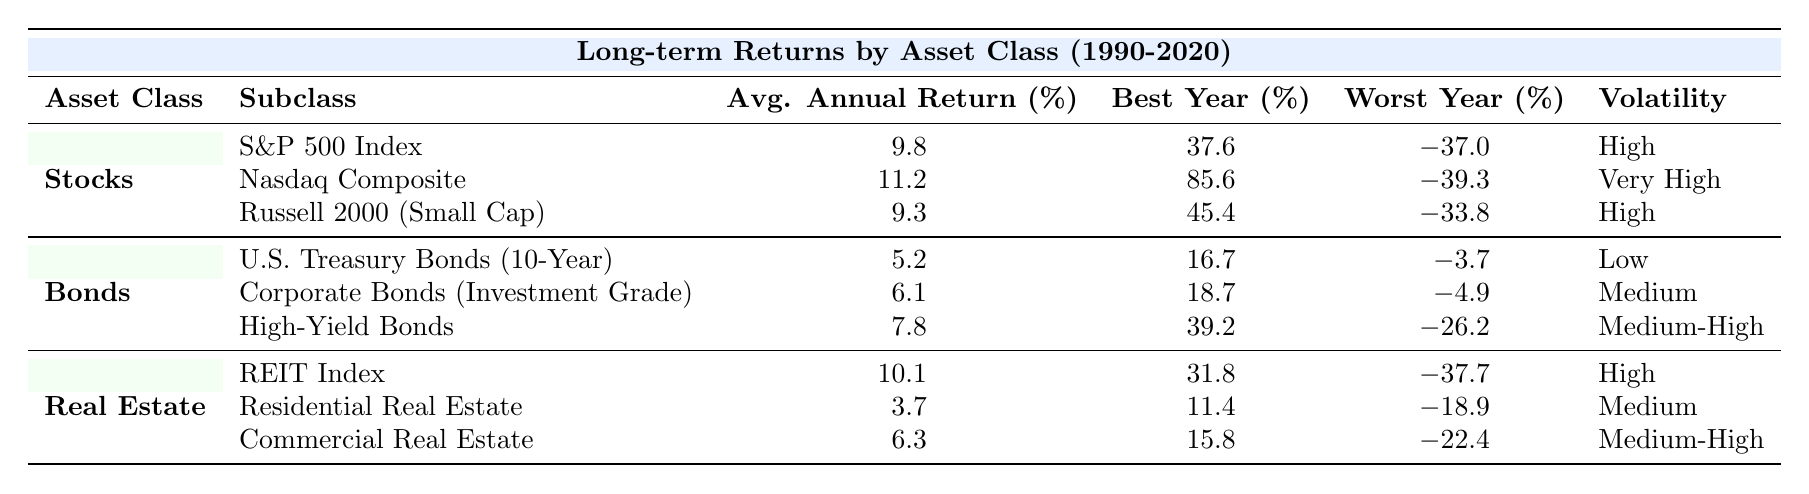What is the average annual return of the Nasdaq Composite? The table lists the average annual return for the Nasdaq Composite as 11.2%.
Answer: 11.2% Which asset class has the highest worst year return? By comparing the worst year returns across asset classes, the Nasdaq Composite has the worst year of -39.3% (2000), but Real Estate (REIT Index) also has a worst year of -37.7% (2008). Since both are similar, Real Estate has the highest worst year return in relative ranking (less negative).
Answer: Real Estate What is the volatility of Corporate Bonds? The table states that the volatility of Corporate Bonds (Investment Grade) is classified as Medium.
Answer: Medium Which asset class has the best average annual return overall? The highest average annual return is from the Nasdaq Composite at 11.2%. Therefore, among asset classes, Stocks would rank highest, specifically the Nasdaq Composite.
Answer: Stocks If you combine the average annual returns of U.S. Treasury Bonds and Corporate Bonds, what is the total? U.S. Treasury Bonds have an average annual return of 5.2% and Corporate Bonds at 6.1%. Adding them gives 5.2 + 6.1 = 11.3%.
Answer: 11.3% Is there any asset class that had a best year return above 30%? Yes, both the Nasdaq Composite (best year return of 85.6% in 1999) and REIT Index (best year return of 31.8% in 2014) had best year returns above 30%.
Answer: Yes What is the average annual return of Real Estate compared to Bonds? The average annual return for Real Estate (10.1% for REIT Index, 3.7% for Residential Real Estate, and 6.3% for Commercial Real Estate) is (10.1 + 3.7 + 6.3) / 3 = 6.7%. The average for Bonds (5.2% for U.S. Treasury Bonds, 6.1% for Corporate Bonds, and 7.8% for High-Yield Bonds) is (5.2 + 6.1 + 7.8) / 3 = 6.3%. Comparing these two averages shows Real Estate (6.7%) is higher than Bonds (6.3%).
Answer: Real Estate is higher What is the worst year for Small Cap Stocks? The worst year for Russell 2000 (Small Cap) Stocks occurred in 2008, with a return of -33.8%.
Answer: -33.8% Between all asset classes, which has the most volatility? The Nasdaq Composite has the highest volatility classified as Very High. There are also High volatility classifications for other asset classes (Stocks and REIT Index).
Answer: Stocks (Nasdaq Composite) If you were to invest in the asset class with the highest average return, which one would it be? The asset class with the highest average annual return from the data provided is the Nasdaq Composite at 11.2%.
Answer: Nasdaq Composite 